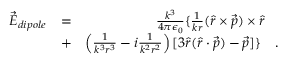Convert formula to latex. <formula><loc_0><loc_0><loc_500><loc_500>\begin{array} { r l r } { \vec { E } _ { d i p o l e } } & { = } & { \frac { k ^ { 3 } } { 4 \pi \epsilon _ { 0 } } \{ \frac { 1 } { k r } ( \hat { r } \times \vec { p } ) \times \hat { r } \quad } \\ & { + } & { \left ( \frac { 1 } { k ^ { 3 } r ^ { 3 } } - i \frac { 1 } { k ^ { 2 } r ^ { 2 } } \right ) [ 3 \hat { r } ( \hat { r } \cdot \vec { p } ) - \vec { p } ] \} \quad . } \end{array}</formula> 